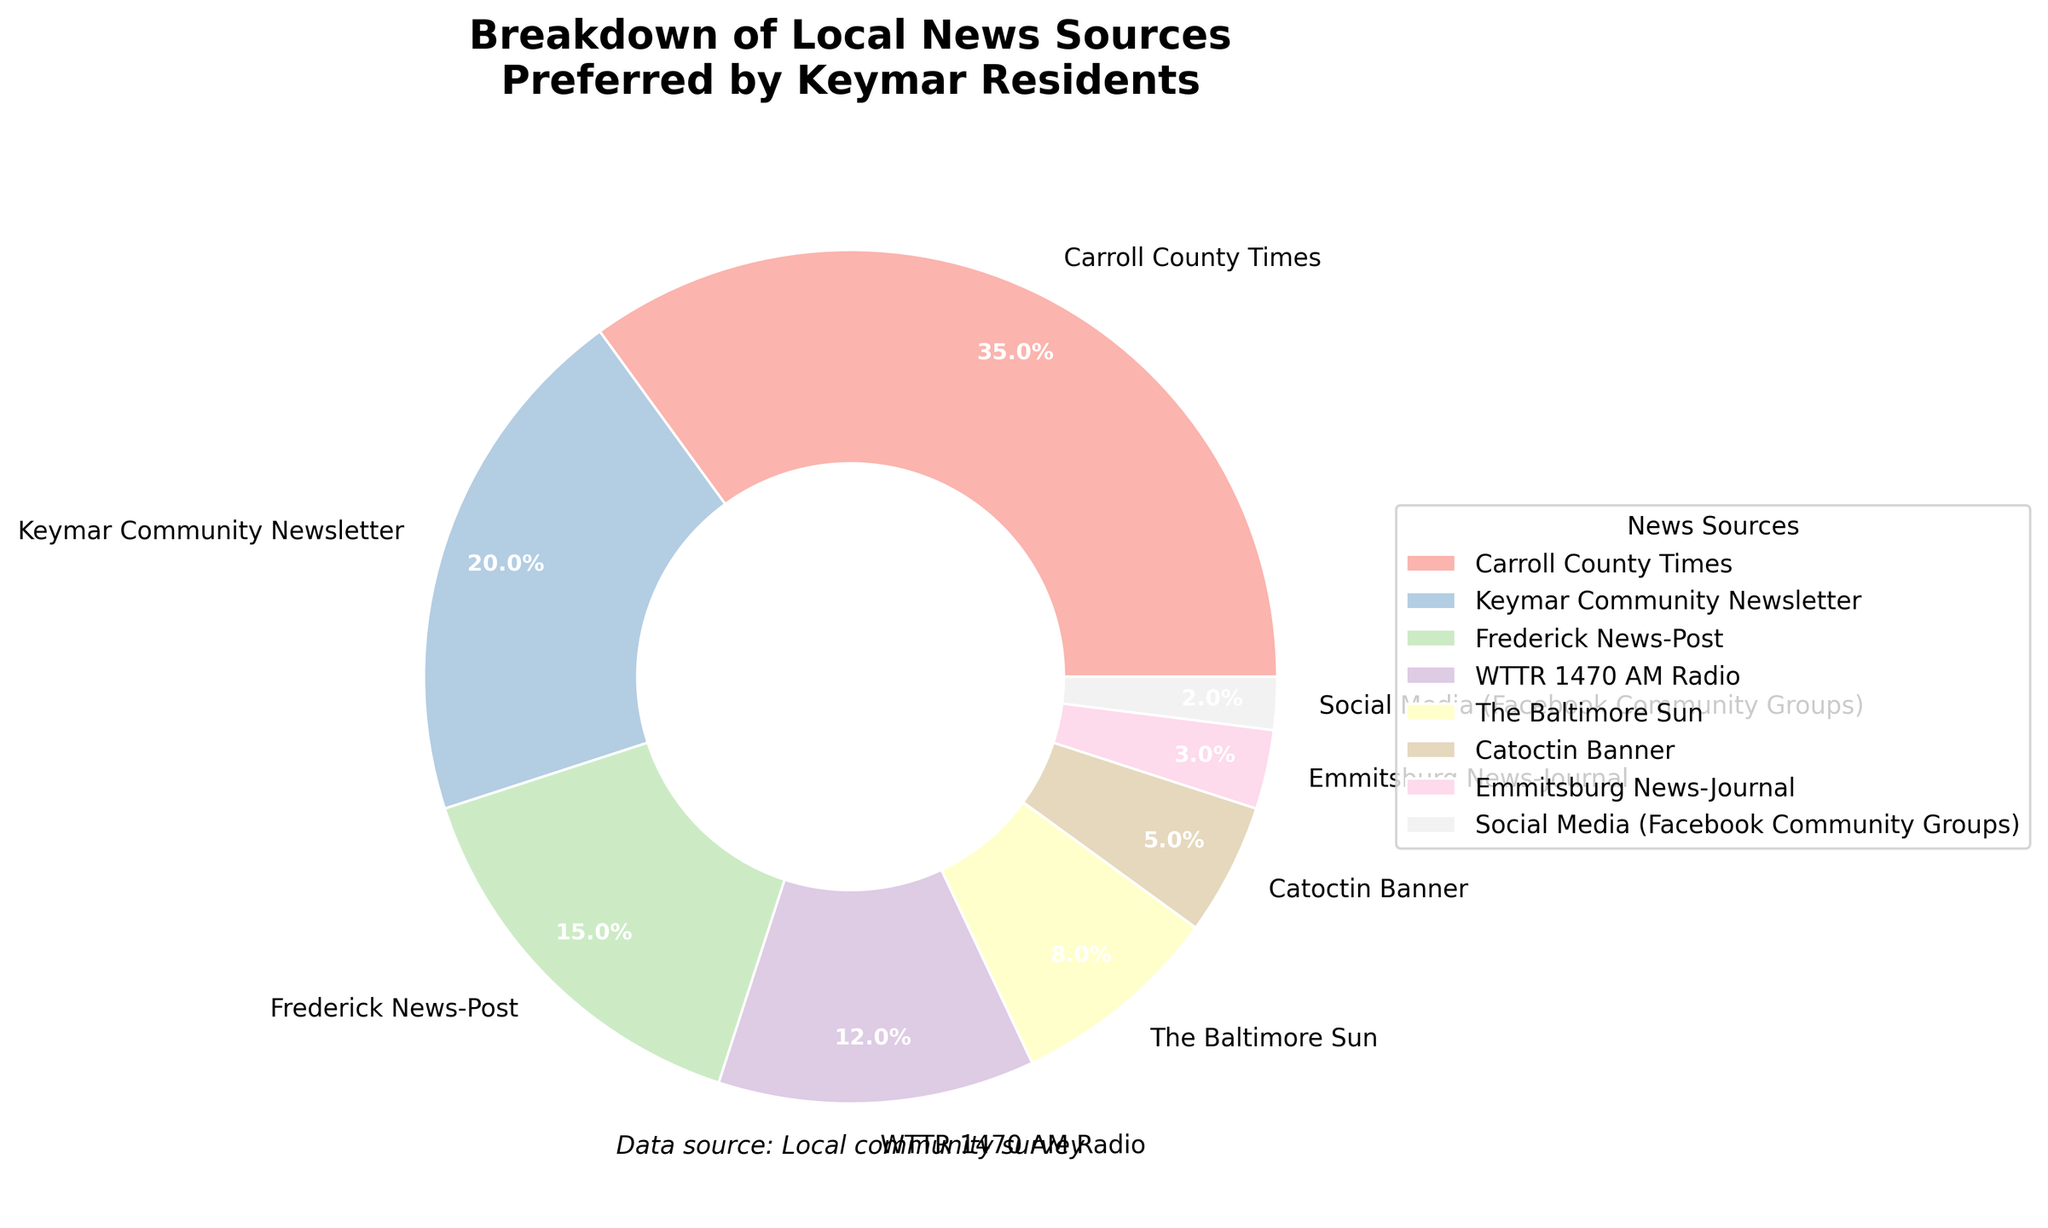Which news source is the most preferred by Keymar residents? The pie chart shows multiple news sources with their respective percentages. The slice with the highest percentage is Carroll County Times at 35%.
Answer: Carroll County Times Which two news sources have the smallest percentages? Looking at the pie chart, the smallest slices represent Social Media (Facebook Community Groups) at 2% and Emmitsburg News-Journal at 3%.
Answer: Social Media (Facebook Community Groups) and Emmitsburg News-Journal What is the combined percentage of the Frederick News-Post and WTTR 1470 AM Radio? To find the combined percentage, add the percentages of the Frederick News-Post (15%) and WTTR 1470 AM Radio (12%): 15% + 12% = 27%.
Answer: 27% Is the percentage of residents preferring the Keymar Community Newsletter more or less than double those preferring the Catoctin Banner? The Keymar Community Newsletter has a percentage of 20%, and the Catoctin Banner has 5%. Doubling the Catoctin Banner's percentage gives 5% * 2 = 10%. Since 20% is greater than 10%, the Keymar Community Newsletter is more preferred.
Answer: More What is the average percentage of all news sources listed? Sum all the percentages and divide by the number of sources: (35 + 20 + 15 + 12 + 8 + 5 + 3 + 2)/8 = 12.5%.
Answer: 12.5% How much greater is the percentage of Carroll County Times compared to The Baltimore Sun? Subtract The Baltimore Sun's percentage from the Carroll County Times' percentage: 35% - 8% = 27%.
Answer: 27% Which news source has a visual representation with a wedge of a distinctly lighter color compared to others? Looking at the chart's colors, the visual slice for Social Media (Facebook Community Groups) stands out with a distinctly lighter color compared to others.
Answer: Social Media (Facebook Community Groups) What is the difference in the combined percentages between Carroll County Times and Keymar Community Newsletter versus all other sources combined? First, find the combined percentage of Carroll County Times and Keymar Community Newsletter: 35% + 20% = 55%. Then, find the combined percentage of the other sources: 100% - 55% = 45%. The difference is 55% - 45% = 10%.
Answer: 10% Which news sources have a percentage at or below 10%? The slices at or below 10% are The Baltimore Sun at 8%, Catoctin Banner at 5%, Emmitsburg News-Journal at 3%, and Social Media (Facebook Community Groups) at 2%.
Answer: The Baltimore Sun, Catoctin Banner, Emmitsburg News-Journal, Social Media (Facebook Community Groups) If you combine the percentages of WTTR 1470 AM Radio, The Baltimore Sun, and Catoctin Banner, would their total be less than Frederick News-Post and Keymar Community Newsletter combined? Add the percentages of WTTR 1470 AM Radio (12%), The Baltimore Sun (8%), and Catoctin Banner (5%): 12% + 8% + 5% = 25%. Then add Frederick News-Post (15%) and Keymar Community Newsletter (20%): 15% + 20% = 35%. Since 25% is less than 35%, the answer is yes.
Answer: Yes 